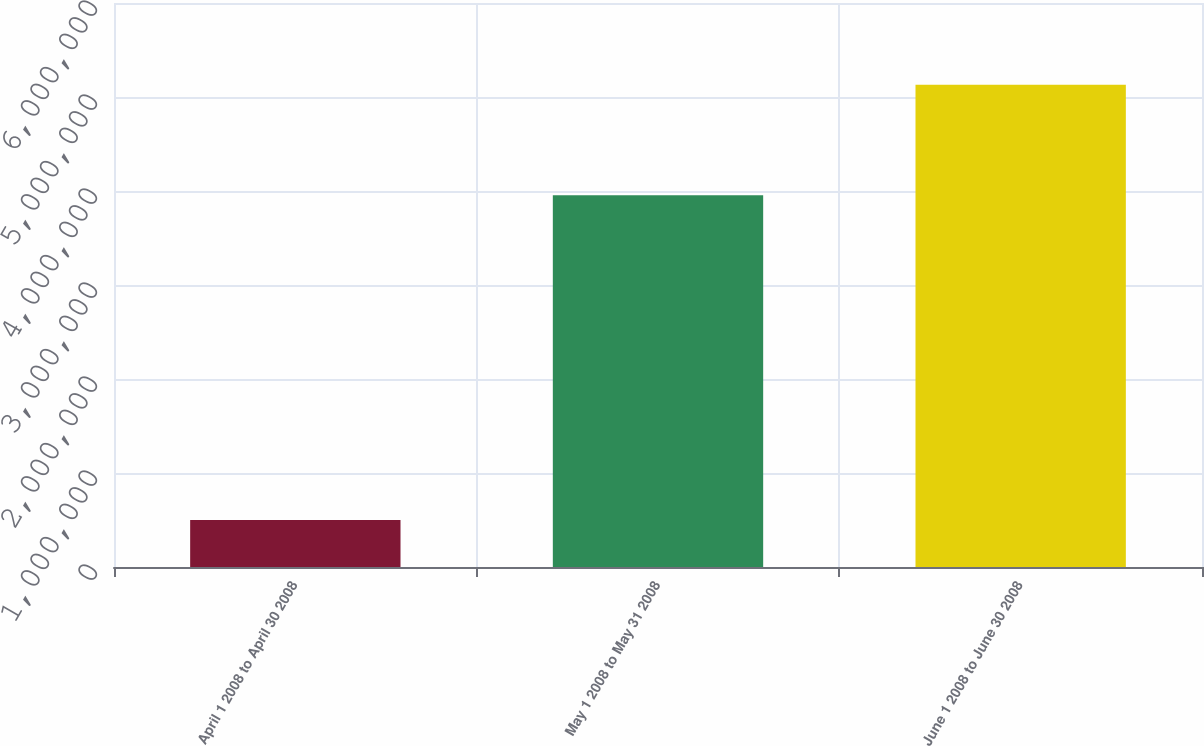Convert chart to OTSL. <chart><loc_0><loc_0><loc_500><loc_500><bar_chart><fcel>April 1 2008 to April 30 2008<fcel>May 1 2008 to May 31 2008<fcel>June 1 2008 to June 30 2008<nl><fcel>500000<fcel>3.956e+06<fcel>5.1308e+06<nl></chart> 